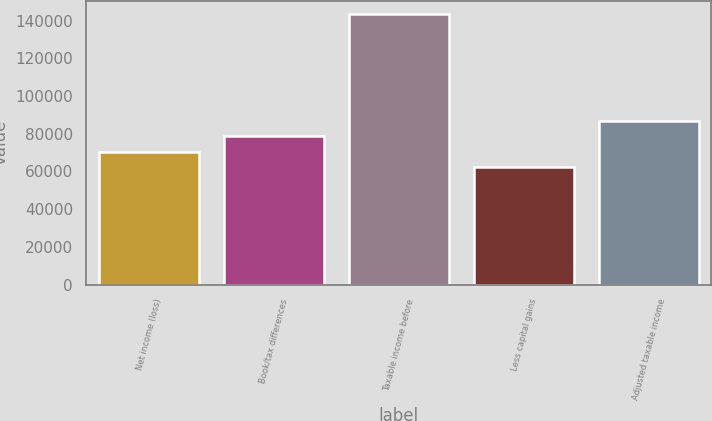Convert chart. <chart><loc_0><loc_0><loc_500><loc_500><bar_chart><fcel>Net income (loss)<fcel>Book/tax differences<fcel>Taxable income before<fcel>Less capital gains<fcel>Adjusted taxable income<nl><fcel>70573.3<fcel>78669.6<fcel>143440<fcel>62477<fcel>86765.9<nl></chart> 